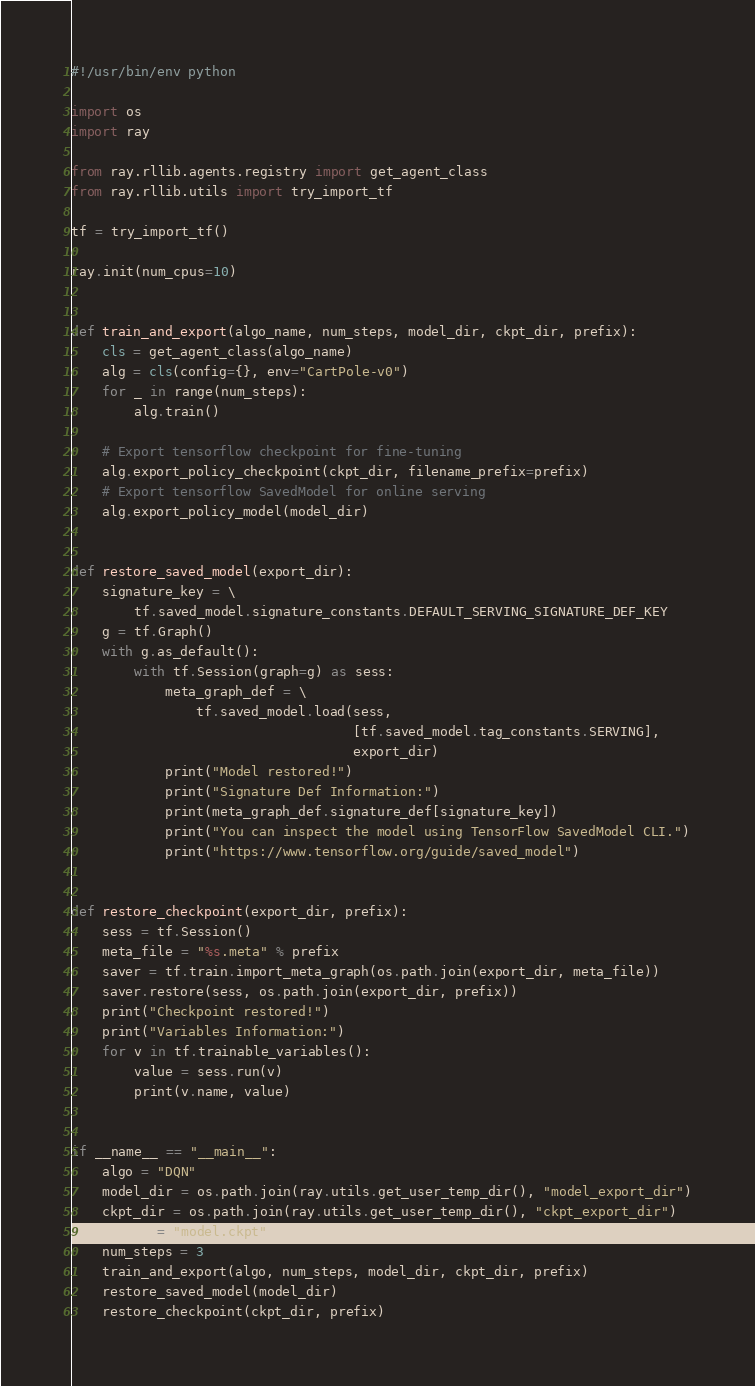Convert code to text. <code><loc_0><loc_0><loc_500><loc_500><_Python_>#!/usr/bin/env python

import os
import ray

from ray.rllib.agents.registry import get_agent_class
from ray.rllib.utils import try_import_tf

tf = try_import_tf()

ray.init(num_cpus=10)


def train_and_export(algo_name, num_steps, model_dir, ckpt_dir, prefix):
    cls = get_agent_class(algo_name)
    alg = cls(config={}, env="CartPole-v0")
    for _ in range(num_steps):
        alg.train()

    # Export tensorflow checkpoint for fine-tuning
    alg.export_policy_checkpoint(ckpt_dir, filename_prefix=prefix)
    # Export tensorflow SavedModel for online serving
    alg.export_policy_model(model_dir)


def restore_saved_model(export_dir):
    signature_key = \
        tf.saved_model.signature_constants.DEFAULT_SERVING_SIGNATURE_DEF_KEY
    g = tf.Graph()
    with g.as_default():
        with tf.Session(graph=g) as sess:
            meta_graph_def = \
                tf.saved_model.load(sess,
                                    [tf.saved_model.tag_constants.SERVING],
                                    export_dir)
            print("Model restored!")
            print("Signature Def Information:")
            print(meta_graph_def.signature_def[signature_key])
            print("You can inspect the model using TensorFlow SavedModel CLI.")
            print("https://www.tensorflow.org/guide/saved_model")


def restore_checkpoint(export_dir, prefix):
    sess = tf.Session()
    meta_file = "%s.meta" % prefix
    saver = tf.train.import_meta_graph(os.path.join(export_dir, meta_file))
    saver.restore(sess, os.path.join(export_dir, prefix))
    print("Checkpoint restored!")
    print("Variables Information:")
    for v in tf.trainable_variables():
        value = sess.run(v)
        print(v.name, value)


if __name__ == "__main__":
    algo = "DQN"
    model_dir = os.path.join(ray.utils.get_user_temp_dir(), "model_export_dir")
    ckpt_dir = os.path.join(ray.utils.get_user_temp_dir(), "ckpt_export_dir")
    prefix = "model.ckpt"
    num_steps = 3
    train_and_export(algo, num_steps, model_dir, ckpt_dir, prefix)
    restore_saved_model(model_dir)
    restore_checkpoint(ckpt_dir, prefix)
</code> 